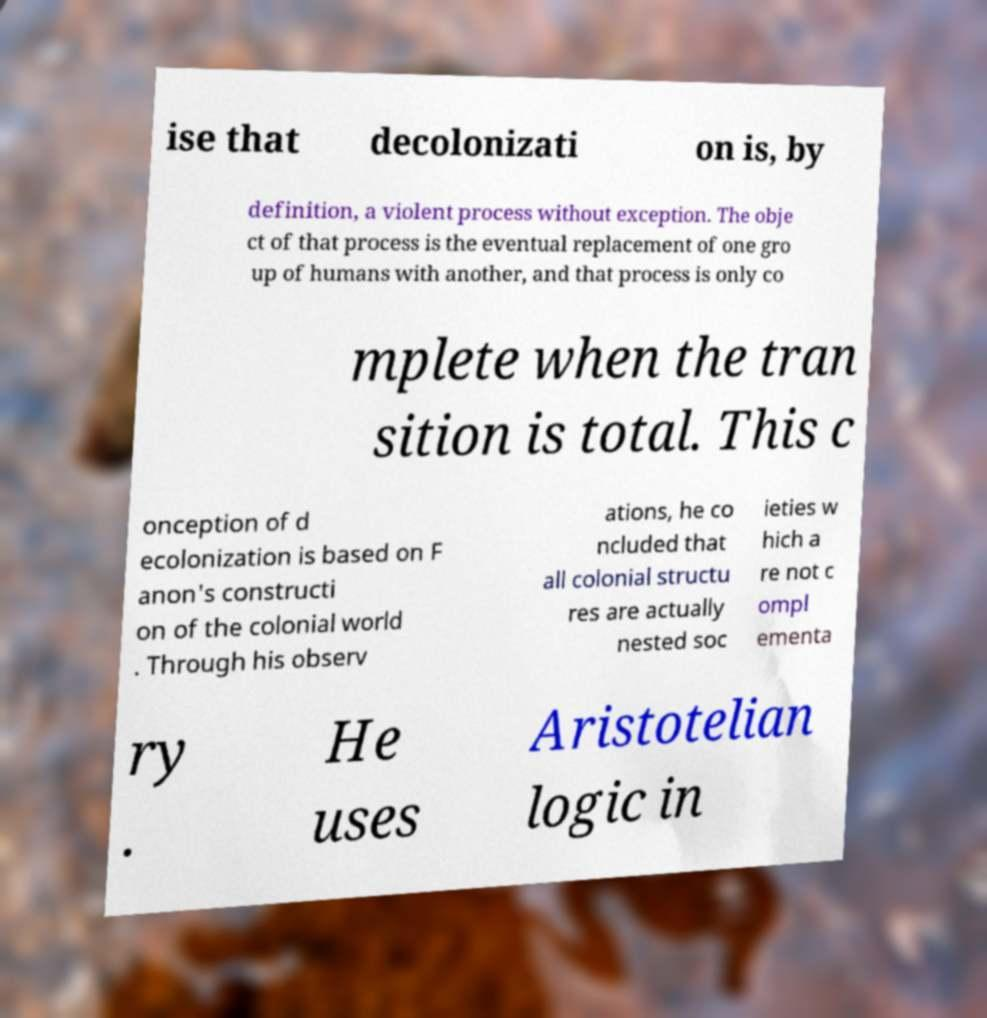Can you read and provide the text displayed in the image?This photo seems to have some interesting text. Can you extract and type it out for me? ise that decolonizati on is, by definition, a violent process without exception. The obje ct of that process is the eventual replacement of one gro up of humans with another, and that process is only co mplete when the tran sition is total. This c onception of d ecolonization is based on F anon's constructi on of the colonial world . Through his observ ations, he co ncluded that all colonial structu res are actually nested soc ieties w hich a re not c ompl ementa ry . He uses Aristotelian logic in 